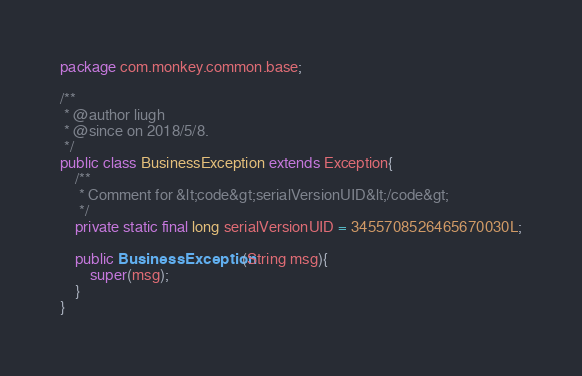<code> <loc_0><loc_0><loc_500><loc_500><_Java_>package com.monkey.common.base;

/**
 * @author liugh
 * @since on 2018/5/8.
 */
public class BusinessException extends Exception{
    /**
     * Comment for &lt;code&gt;serialVersionUID&lt;/code&gt;
     */
    private static final long serialVersionUID = 3455708526465670030L;

    public BusinessException(String msg){
        super(msg);
    }
}</code> 